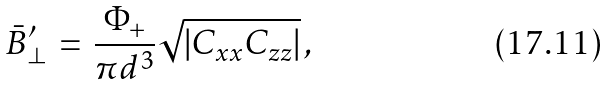Convert formula to latex. <formula><loc_0><loc_0><loc_500><loc_500>\bar { B } _ { \perp } ^ { \prime } \, = \, \frac { \Phi _ { + } } { \pi d ^ { 3 } } \sqrt { | C _ { x x } C _ { z z } | } \, ,</formula> 